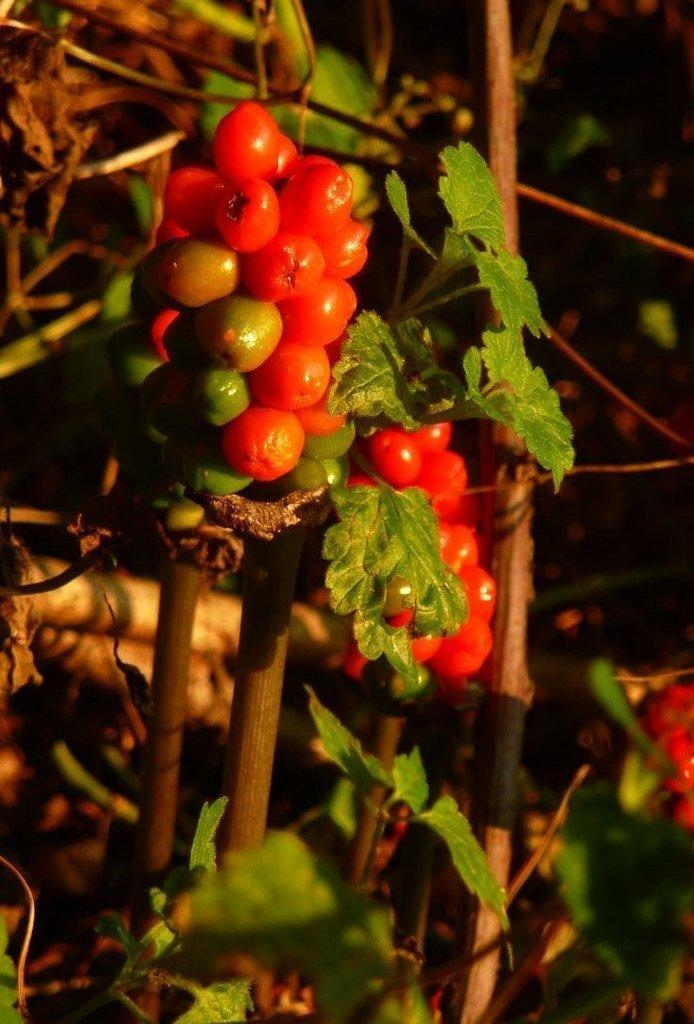What type of fruit is present in the image? The image contains red color cherries. What color are the leaves in the image? The image contains green leaves. What can be seen in the background of the image? There are plants in the background of the image. What type of war is depicted in the image? There is no war depicted in the image; it features cherries and green leaves. How many screws can be seen in the image? There are no screws present in the image. 